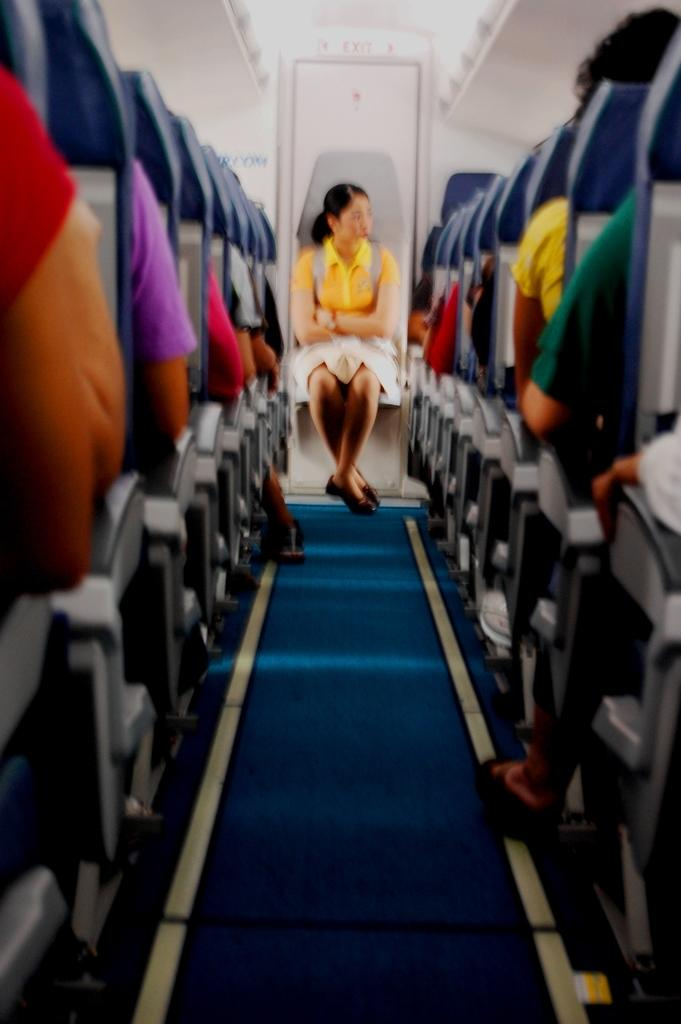What is the woman in the image doing? The woman is sitting in the image. What is the woman wearing? The woman is wearing clothes. What is the woman carrying in the image? The woman is carrying a bag. Are there other people in the image besides the woman? Yes, there are other people sitting in the image. What type of location is depicted in the image? The image depicts an internal structure of a flying jet. What type of oven can be seen in the image? There is no oven present in the image; it depicts an internal structure of a flying jet. Can you tell me how many moms are in the image? The term "mom" is not mentioned in the facts provided, and there is no indication of any familial relationships in the image. 